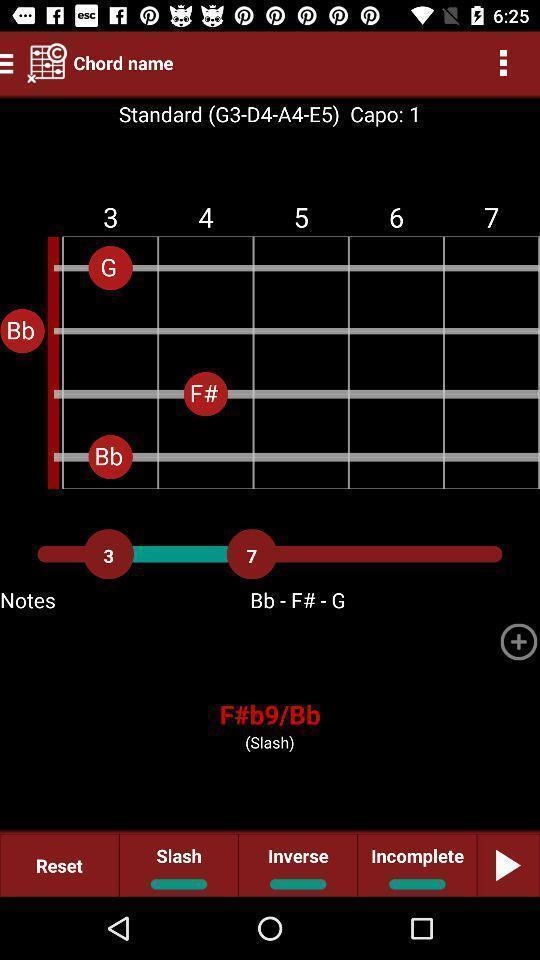Tell me what you see in this picture. Window displaying an app for musician. 